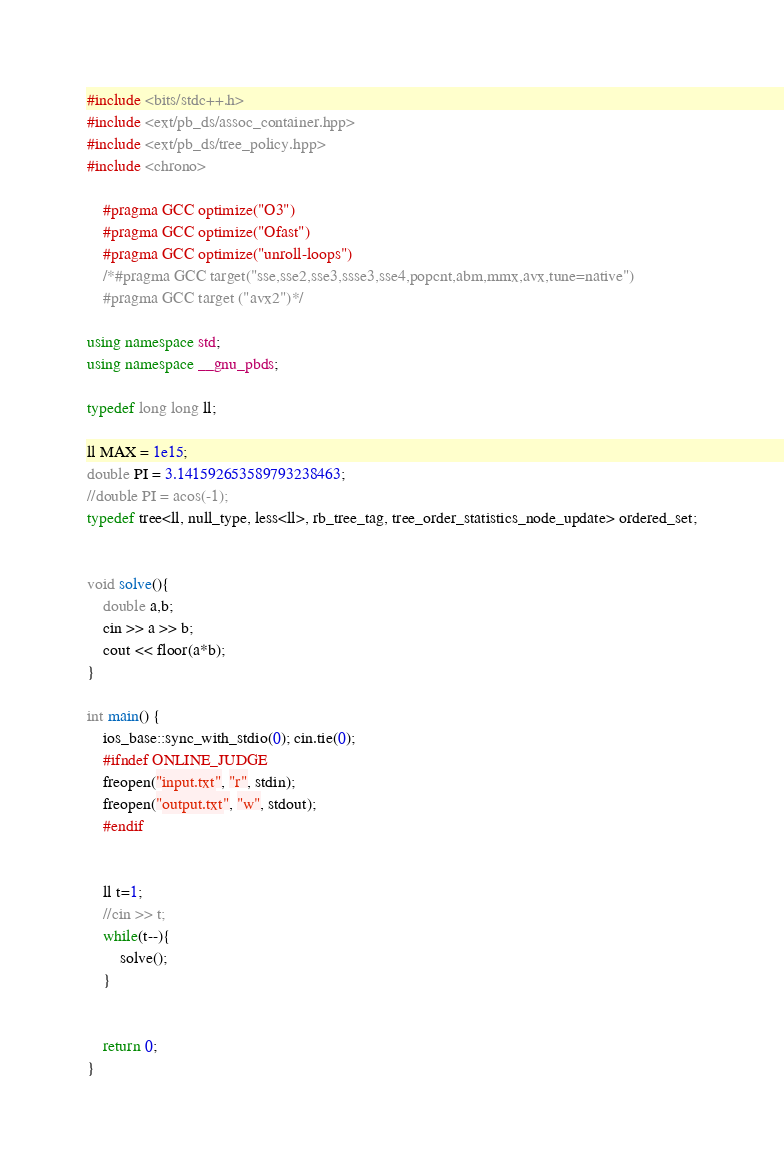Convert code to text. <code><loc_0><loc_0><loc_500><loc_500><_C++_>#include <bits/stdc++.h>
#include <ext/pb_ds/assoc_container.hpp>
#include <ext/pb_ds/tree_policy.hpp>
#include <chrono>

    #pragma GCC optimize("O3")
    #pragma GCC optimize("Ofast")
    #pragma GCC optimize("unroll-loops")
    /*#pragma GCC target("sse,sse2,sse3,ssse3,sse4,popcnt,abm,mmx,avx,tune=native")
    #pragma GCC target ("avx2")*/

using namespace std;
using namespace __gnu_pbds;

typedef long long ll;

ll MAX = 1e15;
double PI = 3.141592653589793238463;
//double PI = acos(-1);
typedef tree<ll, null_type, less<ll>, rb_tree_tag, tree_order_statistics_node_update> ordered_set;


void solve(){
    double a,b;
    cin >> a >> b;
    cout << floor(a*b);
}

int main() {
    ios_base::sync_with_stdio(0); cin.tie(0);
    #ifndef ONLINE_JUDGE
    freopen("input.txt", "r", stdin);
    freopen("output.txt", "w", stdout);
    #endif


    ll t=1;
    //cin >> t;
    while(t--){
        solve();
    }


    return 0;
}
</code> 